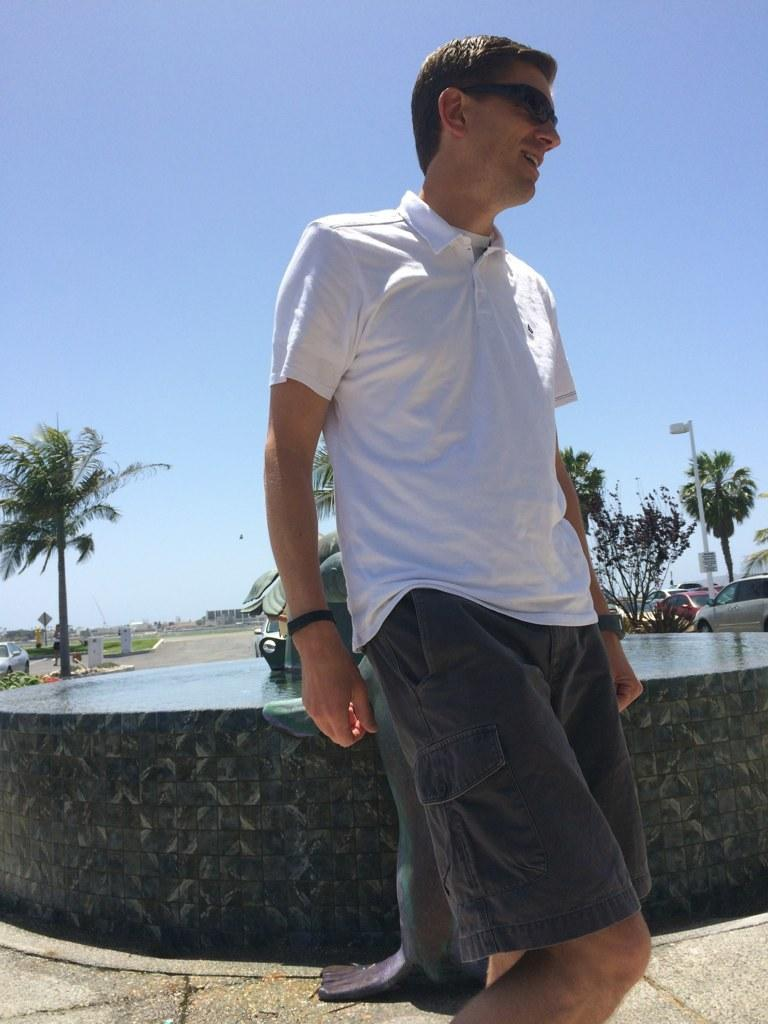Who or what is the main subject in the center of the image? There is a person in the center of the image. What can be seen in the distance behind the person? There are trees and vehicles in the background of the image. What is visible above the trees and vehicles? The sky is visible in the background of the image. What is the surface that the person is standing on? There is a floor at the bottom of the image. What type of juice is being served on the hill in the image? There is no hill or juice present in the image. 